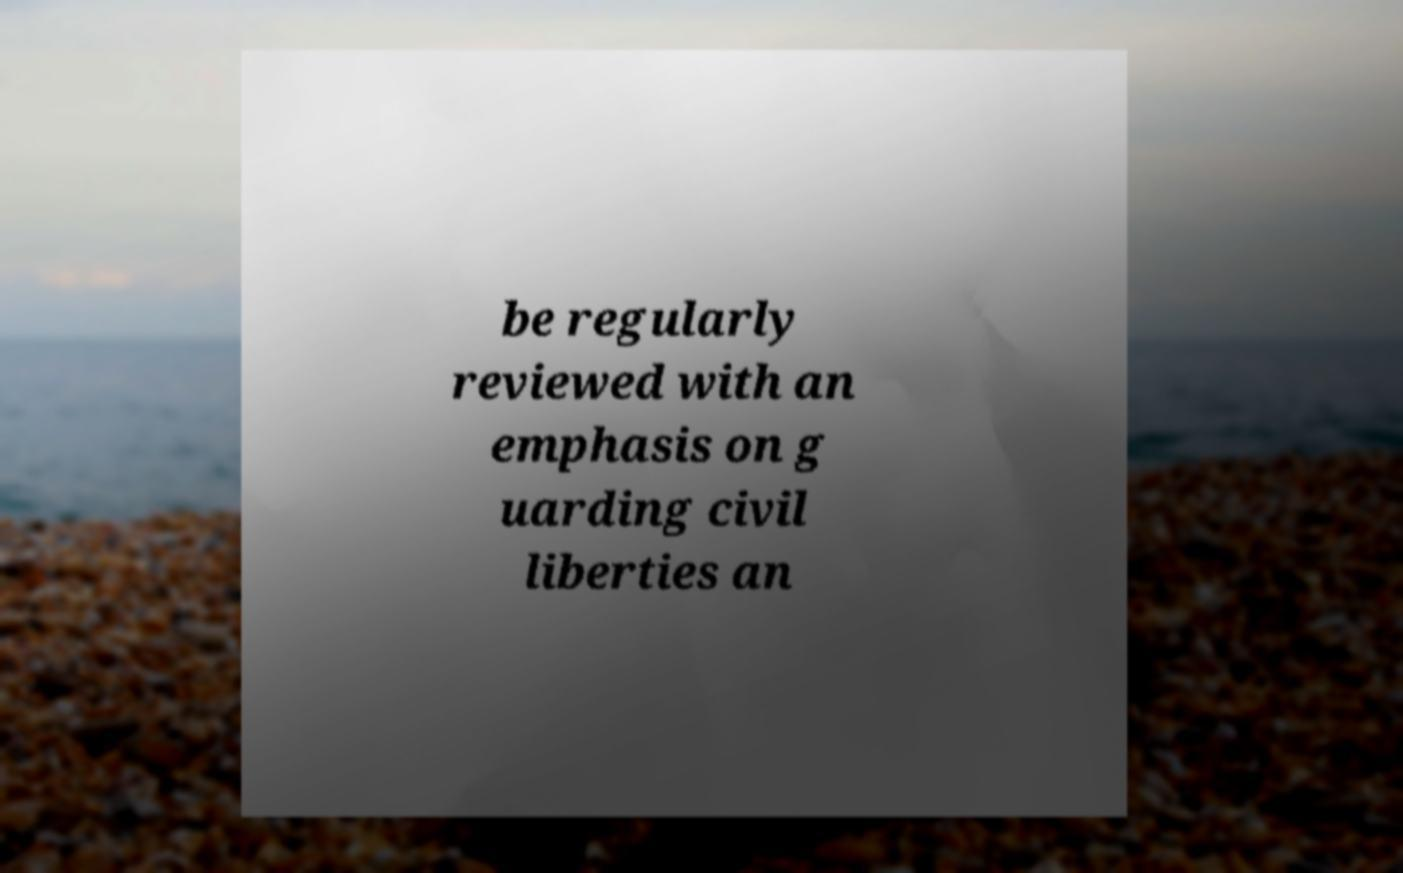There's text embedded in this image that I need extracted. Can you transcribe it verbatim? be regularly reviewed with an emphasis on g uarding civil liberties an 